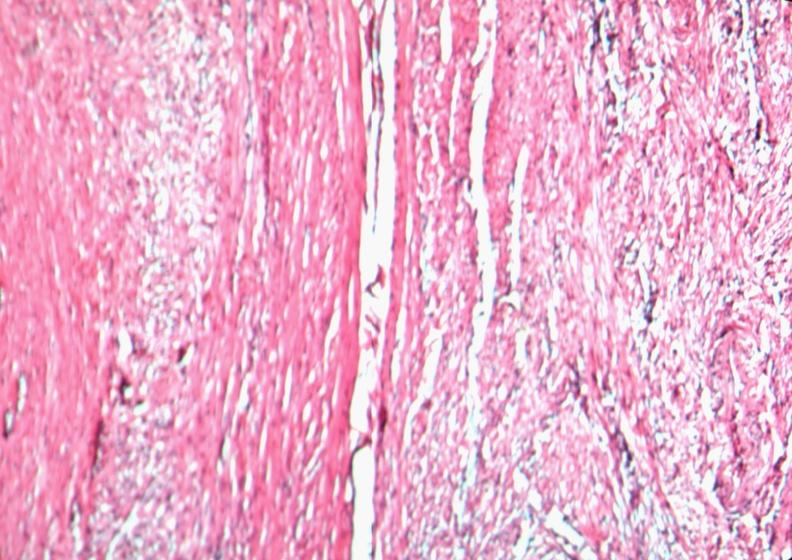what does this image show?
Answer the question using a single word or phrase. Uterus 